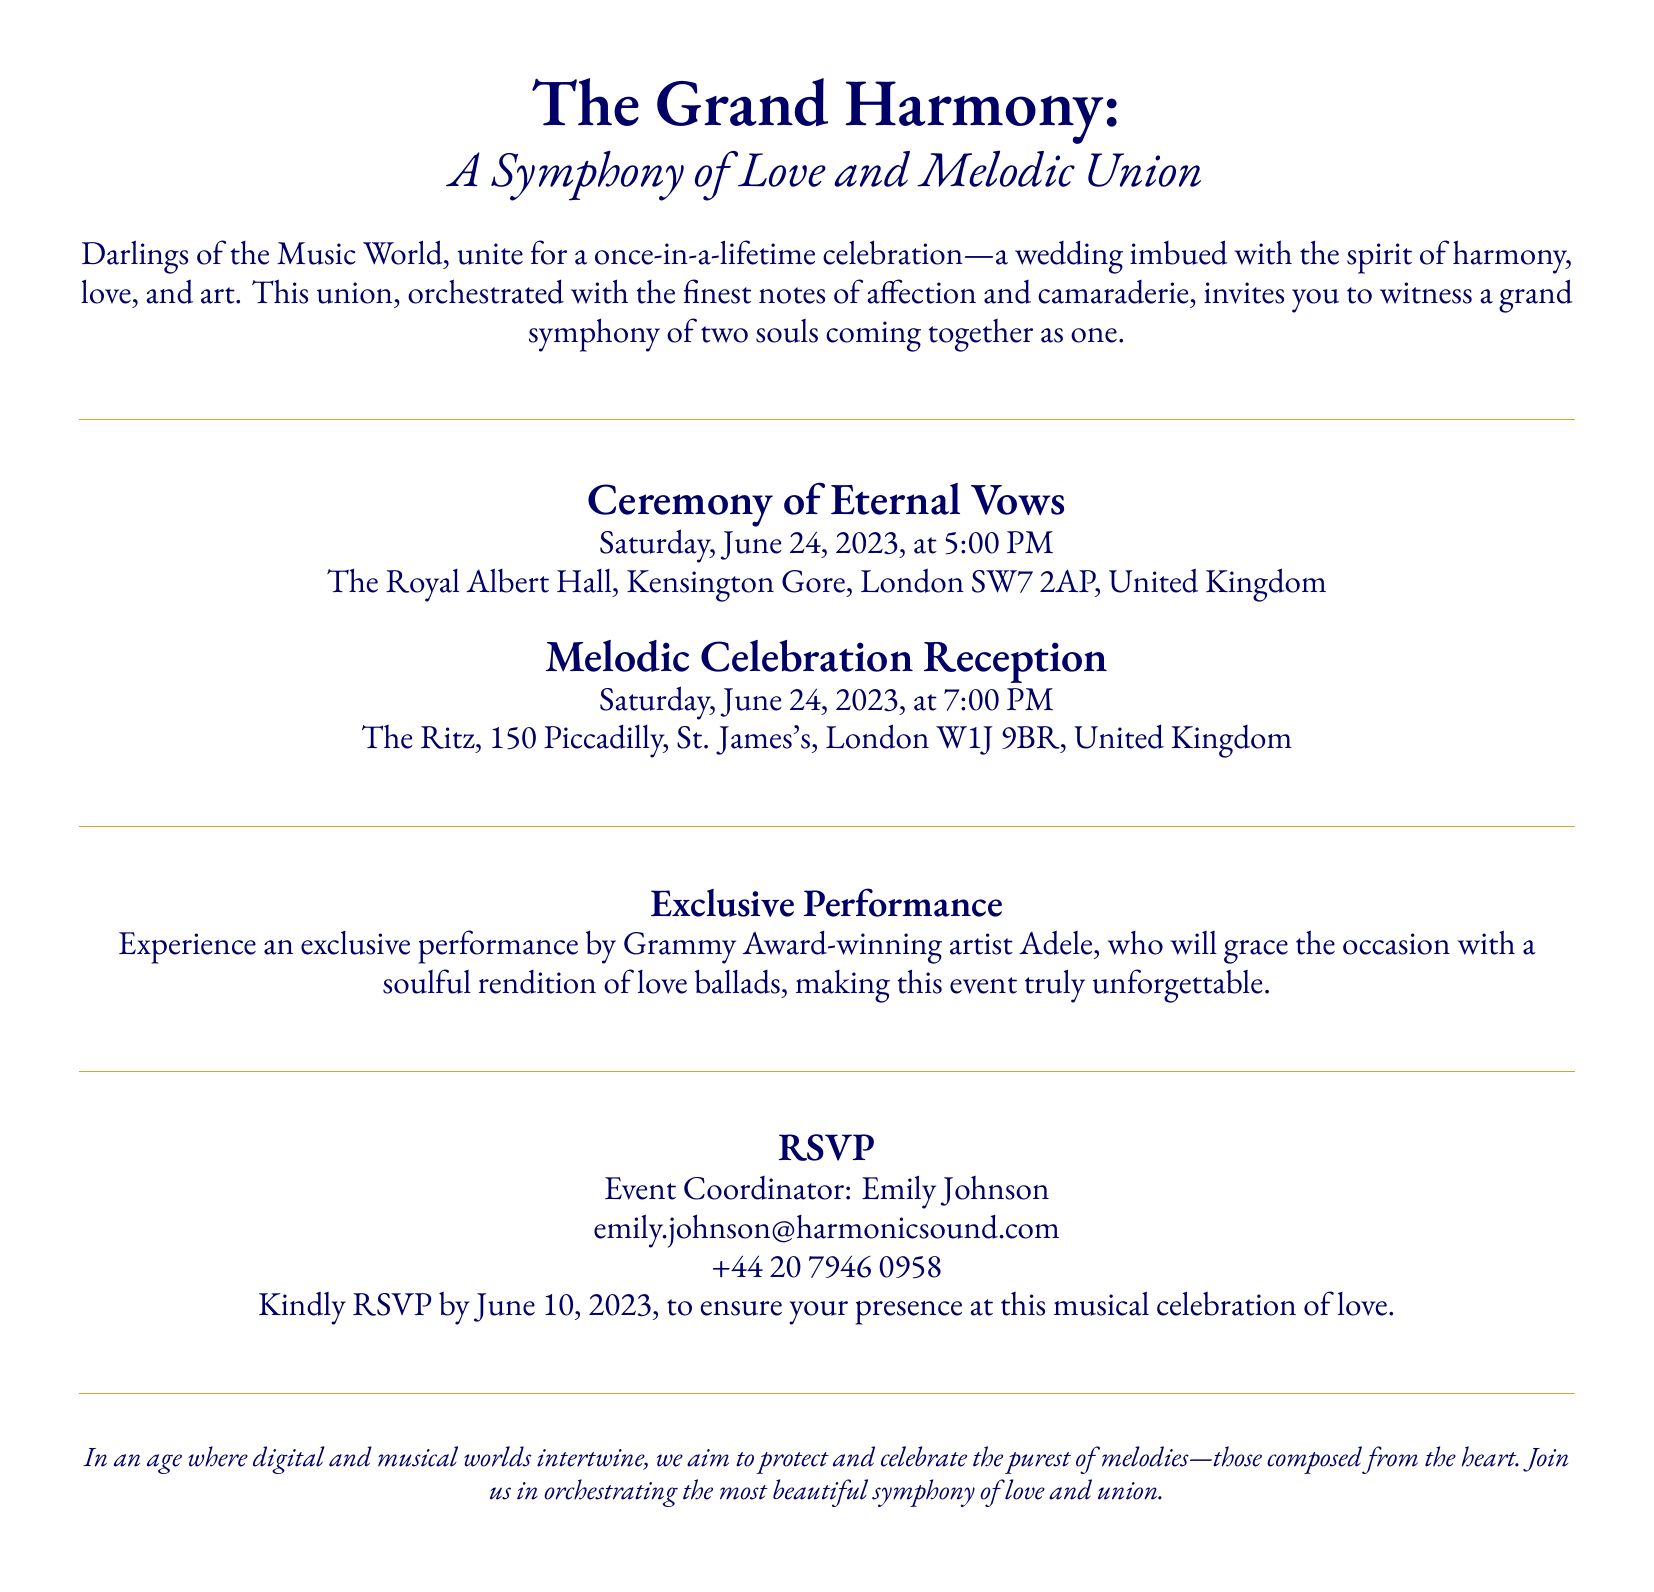What is the title of the event? The title of the event is highlighted at the beginning of the document, stating "The Grand Harmony: A Symphony of Love and Melodic Union."
Answer: The Grand Harmony: A Symphony of Love and Melodic Union When is the wedding ceremony scheduled? The date of the wedding ceremony is mentioned clearly in the document under the Ceremony of Eternal Vows section.
Answer: Saturday, June 24, 2023 Where is the ceremony taking place? The location of the ceremony is provided, detailing the venue and its address.
Answer: The Royal Albert Hall, Kensington Gore, London SW7 2AP, United Kingdom Who is the exclusive performer at the event? The document highlights a special performance by a famous artist, specifically mentioning her name in the Exclusive Performance section.
Answer: Adele What time does the reception start? The reception time is specified in the Melodic Celebration Reception section of the invitation.
Answer: 7:00 PM What is the RSVP deadline? The invitation states the date by which guests should confirm their attendance, found in the RSVP section.
Answer: June 10, 2023 What organization is the event coordinator from? The coordinator's email address suggests the name of the organization responsible for organizing the event.
Answer: Harmonic Sound What type of event is this document describing? The overall nature of the gathering is clarified in the introductory paragraph, identifying it as a personal celebration.
Answer: Wedding 